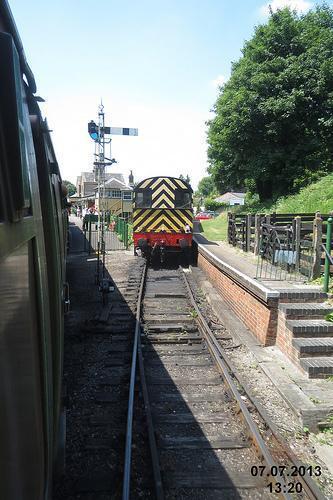How many steps lead up to the platform?
Give a very brief answer. 4. How many trains are in the picture?
Give a very brief answer. 2. 